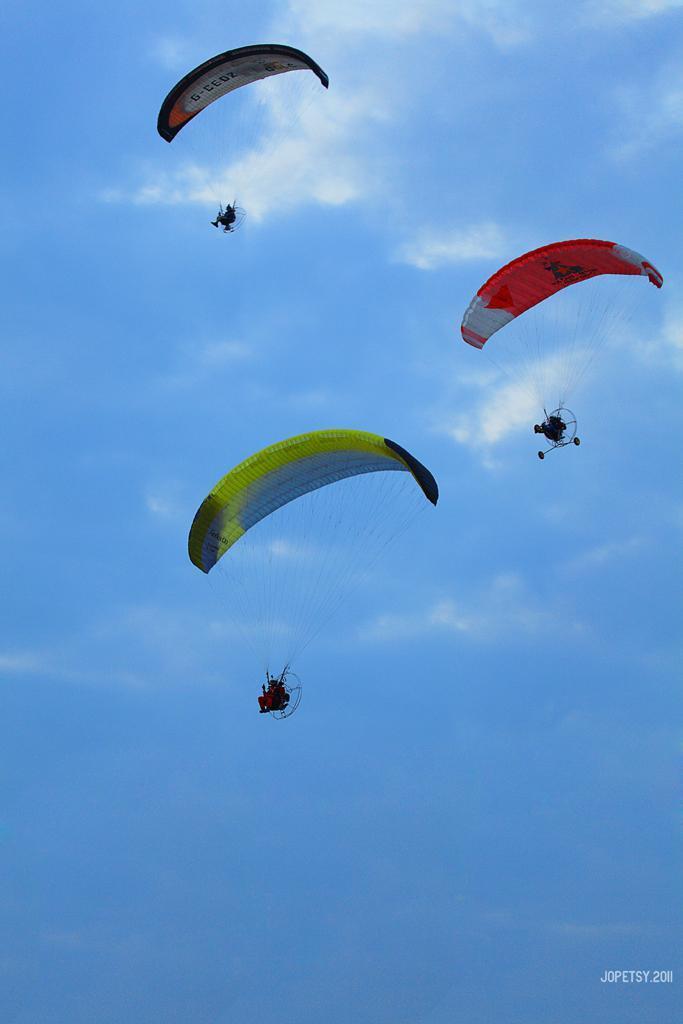In one or two sentences, can you explain what this image depicts? In this picture we can see few people are doing paragliding, they are in the air, and we can see clouds, at the right bottom of the image we can find a watermark. 